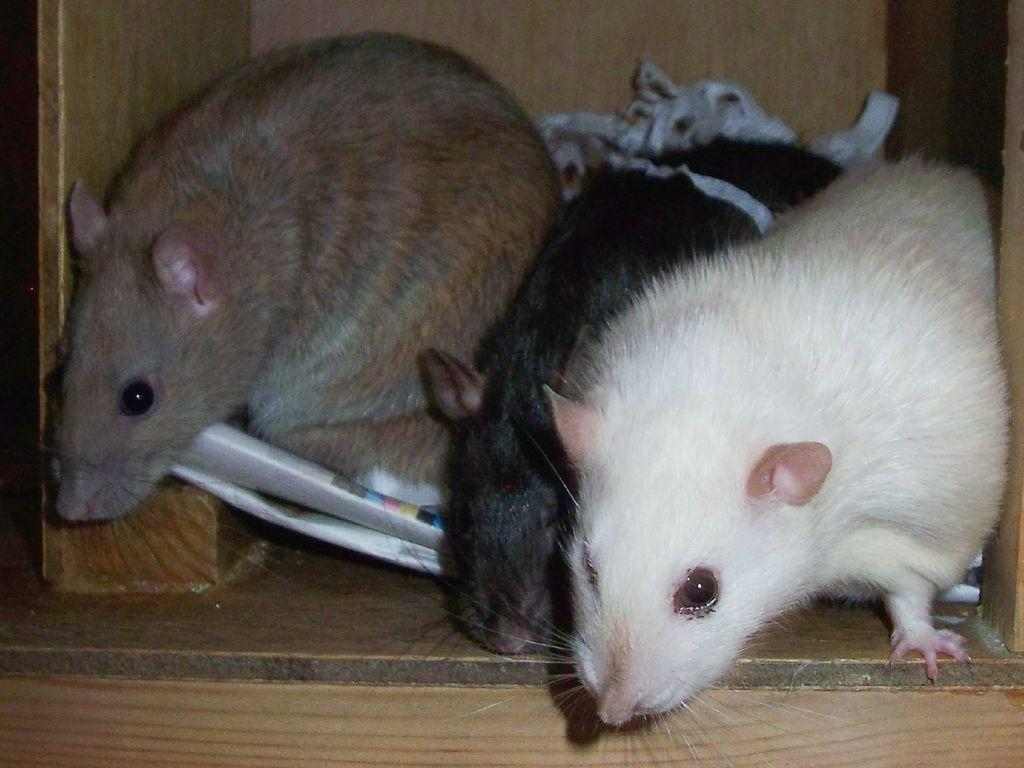What type of animals are present in the image? There are rats in the image. What else can be seen in the image besides the rats? There is paper in the image. Where are the rats and paper located? The paper and rats are inside a wooden cupboard. What type of lunch is being prepared in the image? There is no indication of any lunch preparation in the image; it features rats and paper inside a wooden cupboard. 